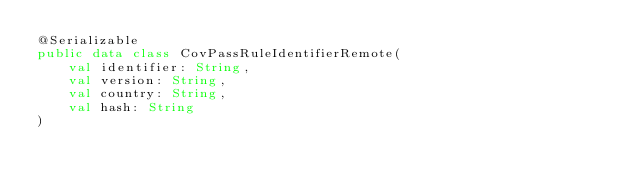<code> <loc_0><loc_0><loc_500><loc_500><_Kotlin_>@Serializable
public data class CovPassRuleIdentifierRemote(
    val identifier: String,
    val version: String,
    val country: String,
    val hash: String
)
</code> 